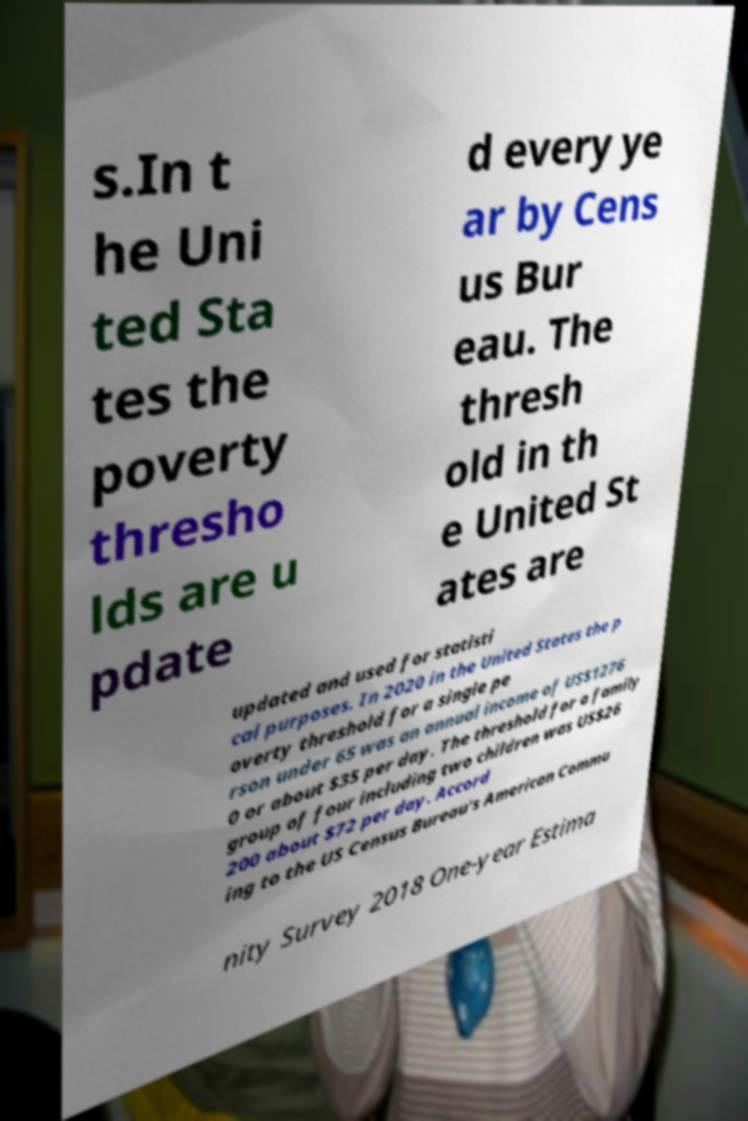Could you assist in decoding the text presented in this image and type it out clearly? s.In t he Uni ted Sta tes the poverty thresho lds are u pdate d every ye ar by Cens us Bur eau. The thresh old in th e United St ates are updated and used for statisti cal purposes. In 2020 in the United States the p overty threshold for a single pe rson under 65 was an annual income of US$1276 0 or about $35 per day. The threshold for a family group of four including two children was US$26 200 about $72 per day. Accord ing to the US Census Bureau's American Commu nity Survey 2018 One-year Estima 